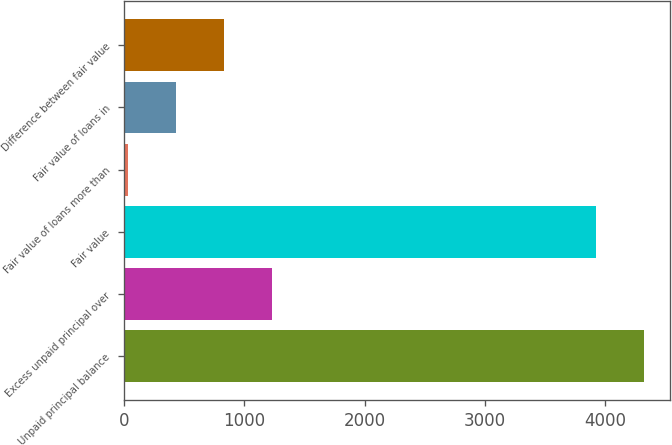Convert chart to OTSL. <chart><loc_0><loc_0><loc_500><loc_500><bar_chart><fcel>Unpaid principal balance<fcel>Excess unpaid principal over<fcel>Fair value<fcel>Fair value of loans more than<fcel>Fair value of loans in<fcel>Difference between fair value<nl><fcel>4320.9<fcel>1230.7<fcel>3922<fcel>34<fcel>432.9<fcel>831.8<nl></chart> 